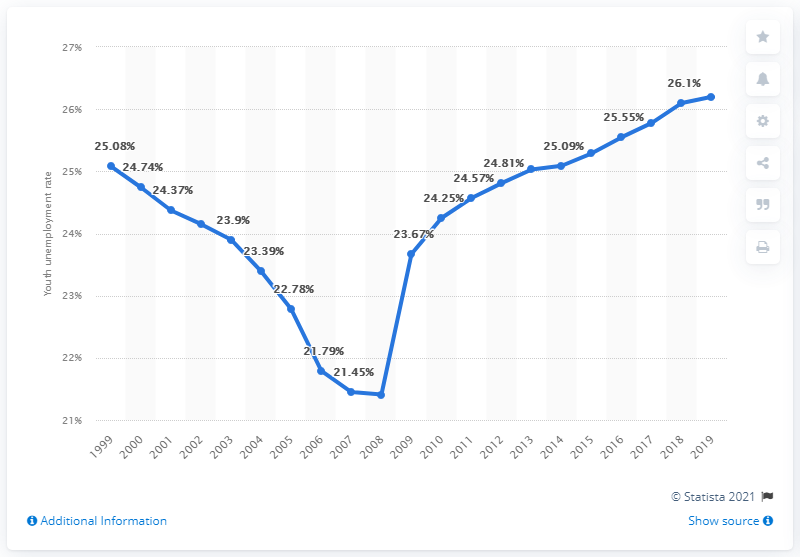Point out several critical features in this image. In 2019, the youth unemployment rate in Guyana was 26.2%. 